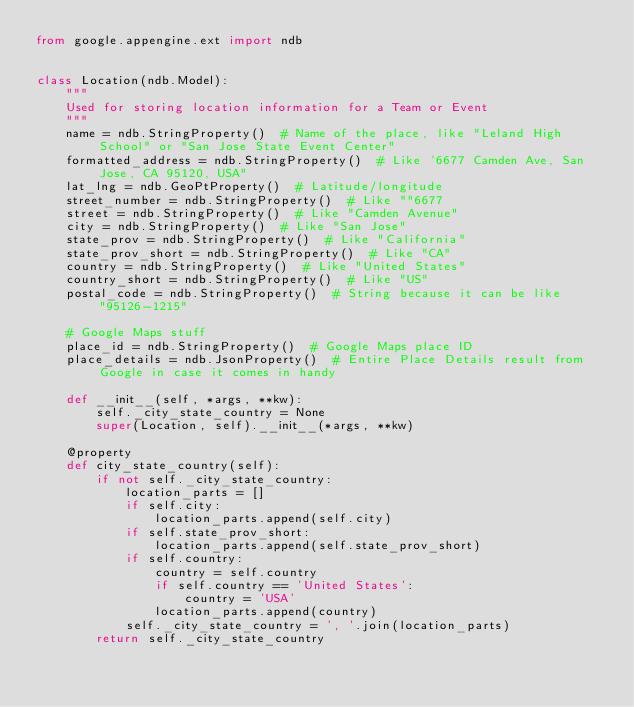Convert code to text. <code><loc_0><loc_0><loc_500><loc_500><_Python_>from google.appengine.ext import ndb


class Location(ndb.Model):
    """
    Used for storing location information for a Team or Event
    """
    name = ndb.StringProperty()  # Name of the place, like "Leland High School" or "San Jose State Event Center"
    formatted_address = ndb.StringProperty()  # Like '6677 Camden Ave, San Jose, CA 95120, USA"
    lat_lng = ndb.GeoPtProperty()  # Latitude/longitude
    street_number = ndb.StringProperty()  # Like ""6677
    street = ndb.StringProperty()  # Like "Camden Avenue"
    city = ndb.StringProperty()  # Like "San Jose"
    state_prov = ndb.StringProperty()  # Like "California"
    state_prov_short = ndb.StringProperty()  # Like "CA"
    country = ndb.StringProperty()  # Like "United States"
    country_short = ndb.StringProperty()  # Like "US"
    postal_code = ndb.StringProperty()  # String because it can be like "95126-1215"

    # Google Maps stuff
    place_id = ndb.StringProperty()  # Google Maps place ID
    place_details = ndb.JsonProperty()  # Entire Place Details result from Google in case it comes in handy

    def __init__(self, *args, **kw):
        self._city_state_country = None
        super(Location, self).__init__(*args, **kw)

    @property
    def city_state_country(self):
        if not self._city_state_country:
            location_parts = []
            if self.city:
                location_parts.append(self.city)
            if self.state_prov_short:
                location_parts.append(self.state_prov_short)
            if self.country:
                country = self.country
                if self.country == 'United States':
                    country = 'USA'
                location_parts.append(country)
            self._city_state_country = ', '.join(location_parts)
        return self._city_state_country
</code> 